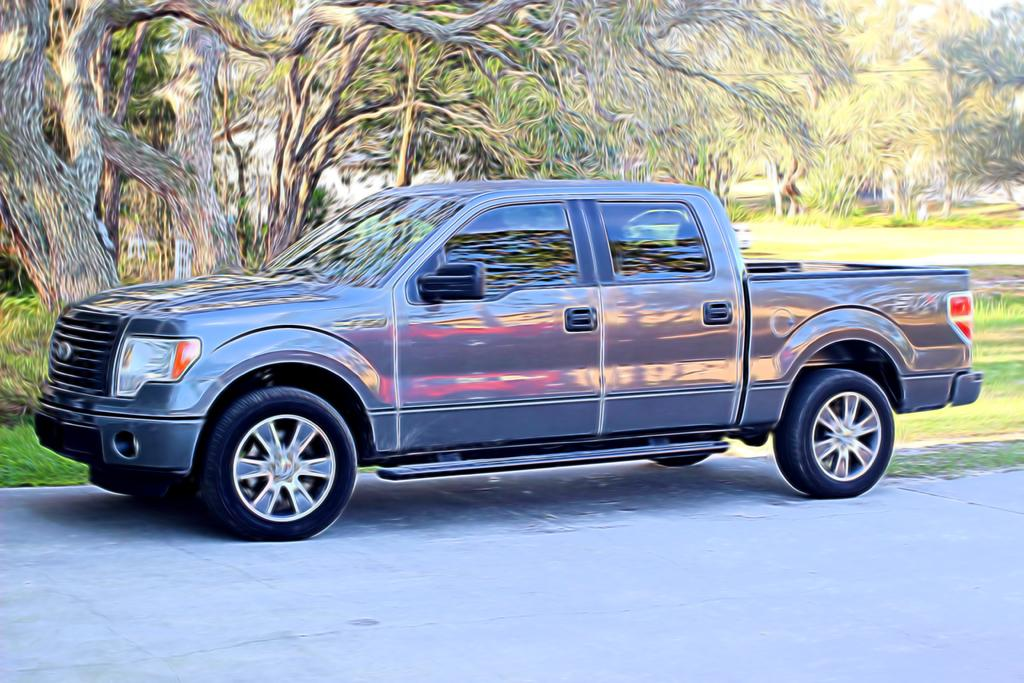What is the main subject in the image? There is a vehicle in the image. What type of natural environment is visible in the image? There are trees and grass in the image. How many clams can be seen in the image? There are no clams present in the image. What time of day is depicted in the image? The provided facts do not give any information about the time of day, so it cannot be determined from the image. 